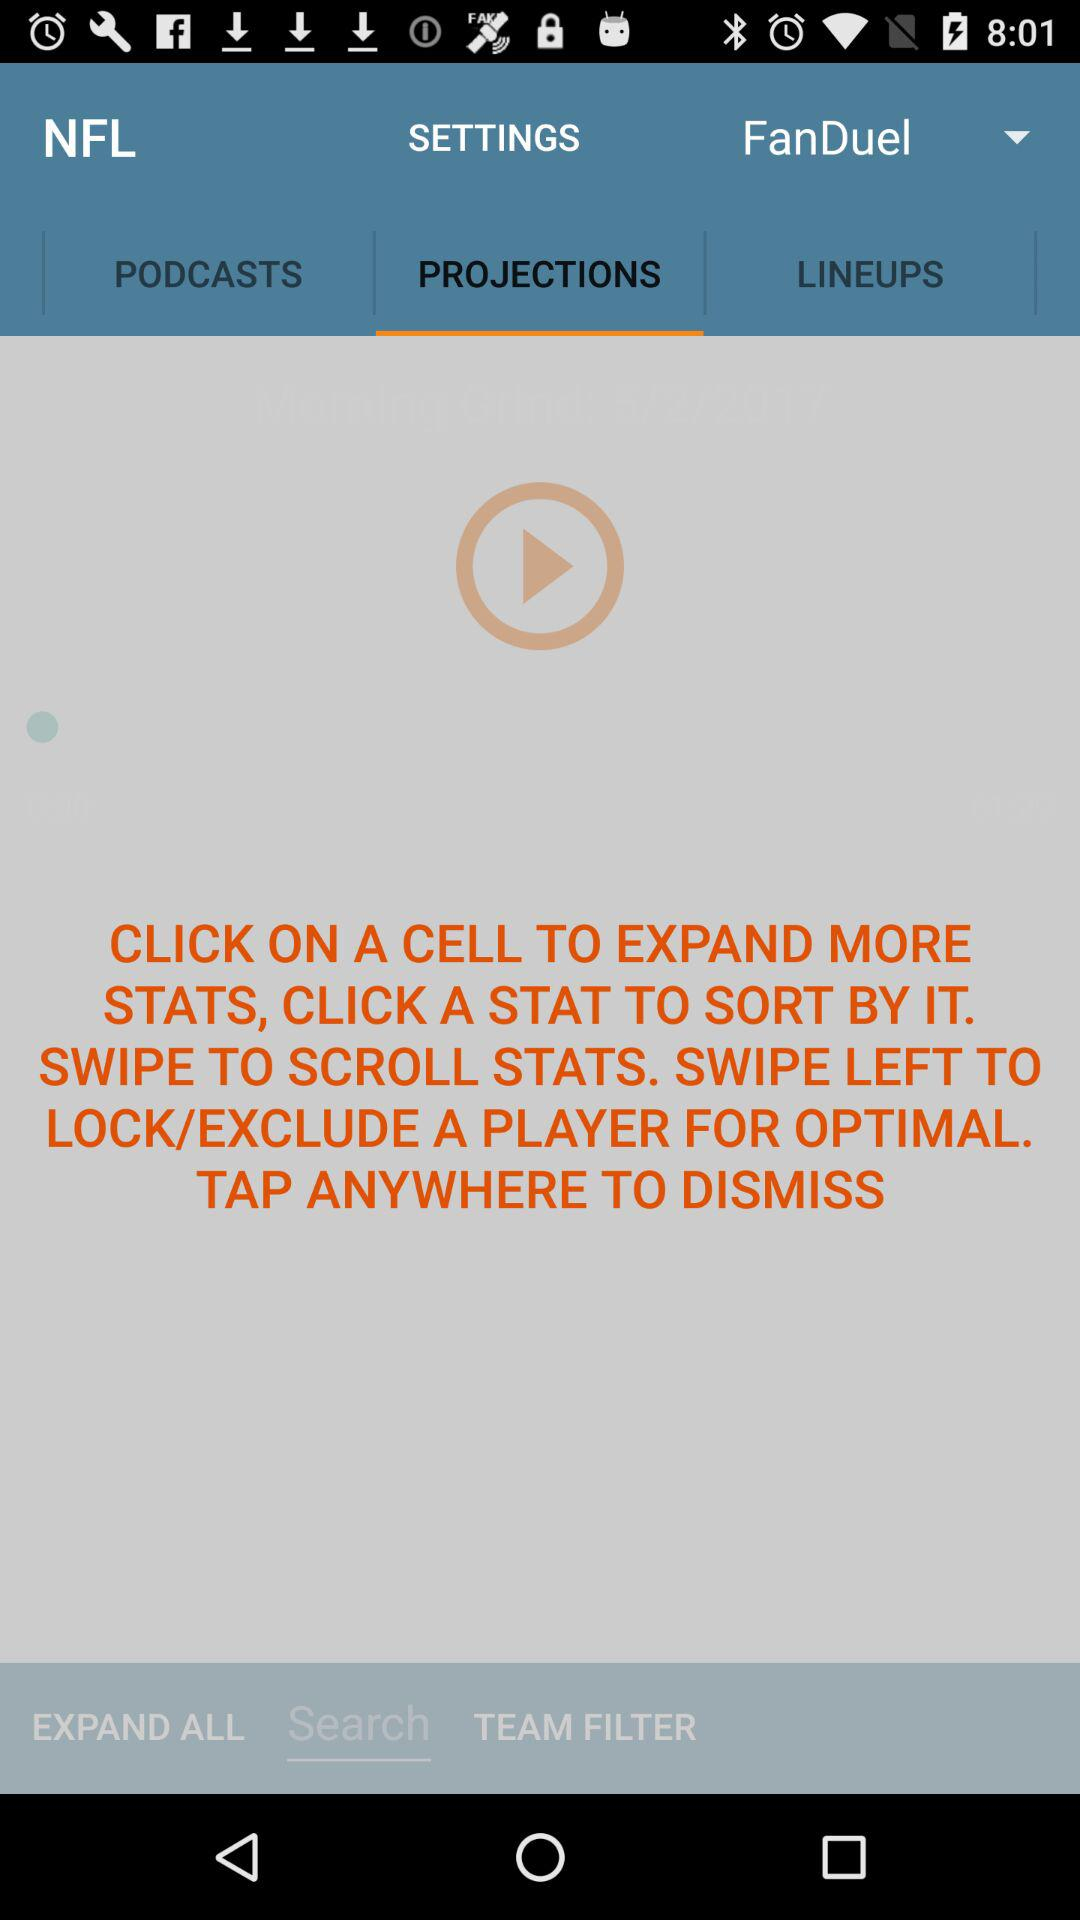Which option is selected? The selected options are "Projections" and "Search". 